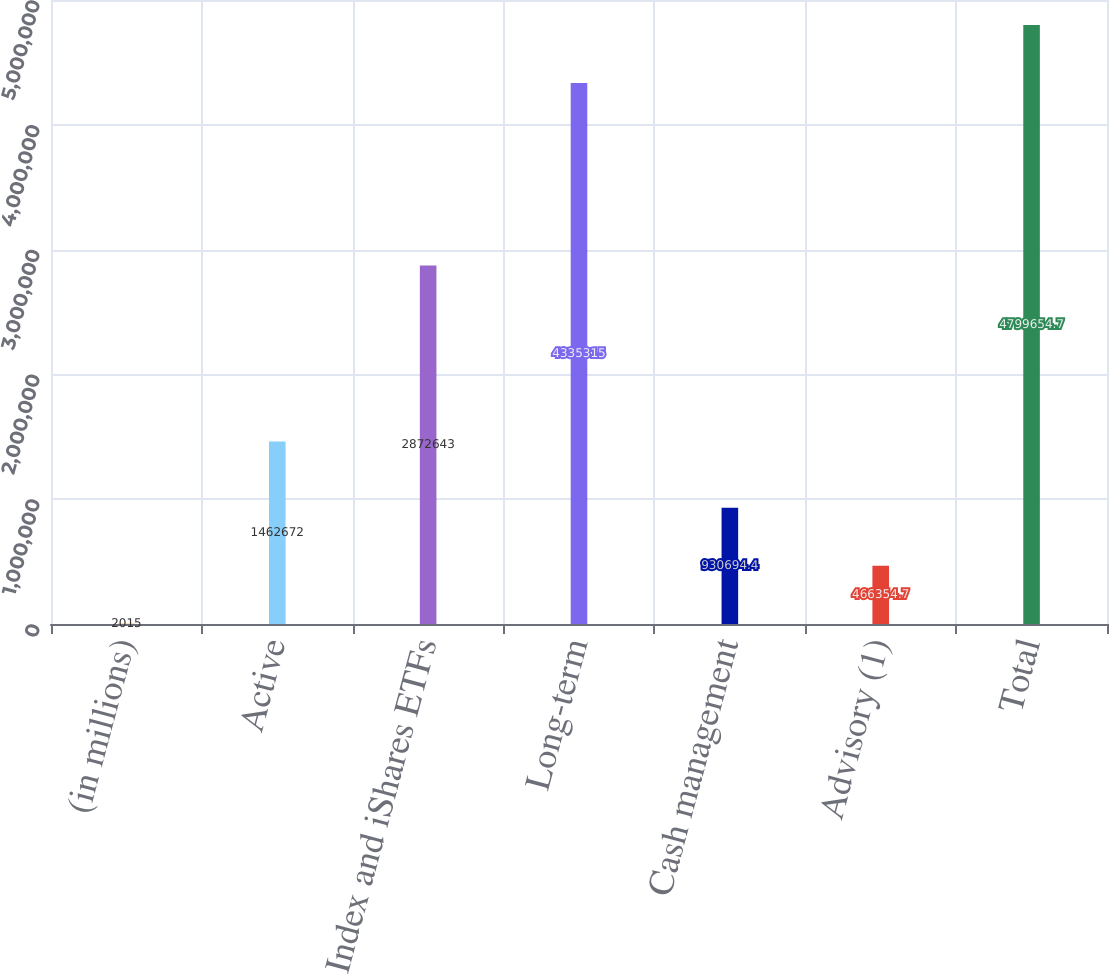<chart> <loc_0><loc_0><loc_500><loc_500><bar_chart><fcel>(in millions)<fcel>Active<fcel>Index and iShares ETFs<fcel>Long-term<fcel>Cash management<fcel>Advisory (1)<fcel>Total<nl><fcel>2015<fcel>1.46267e+06<fcel>2.87264e+06<fcel>4.33532e+06<fcel>930694<fcel>466355<fcel>4.79965e+06<nl></chart> 